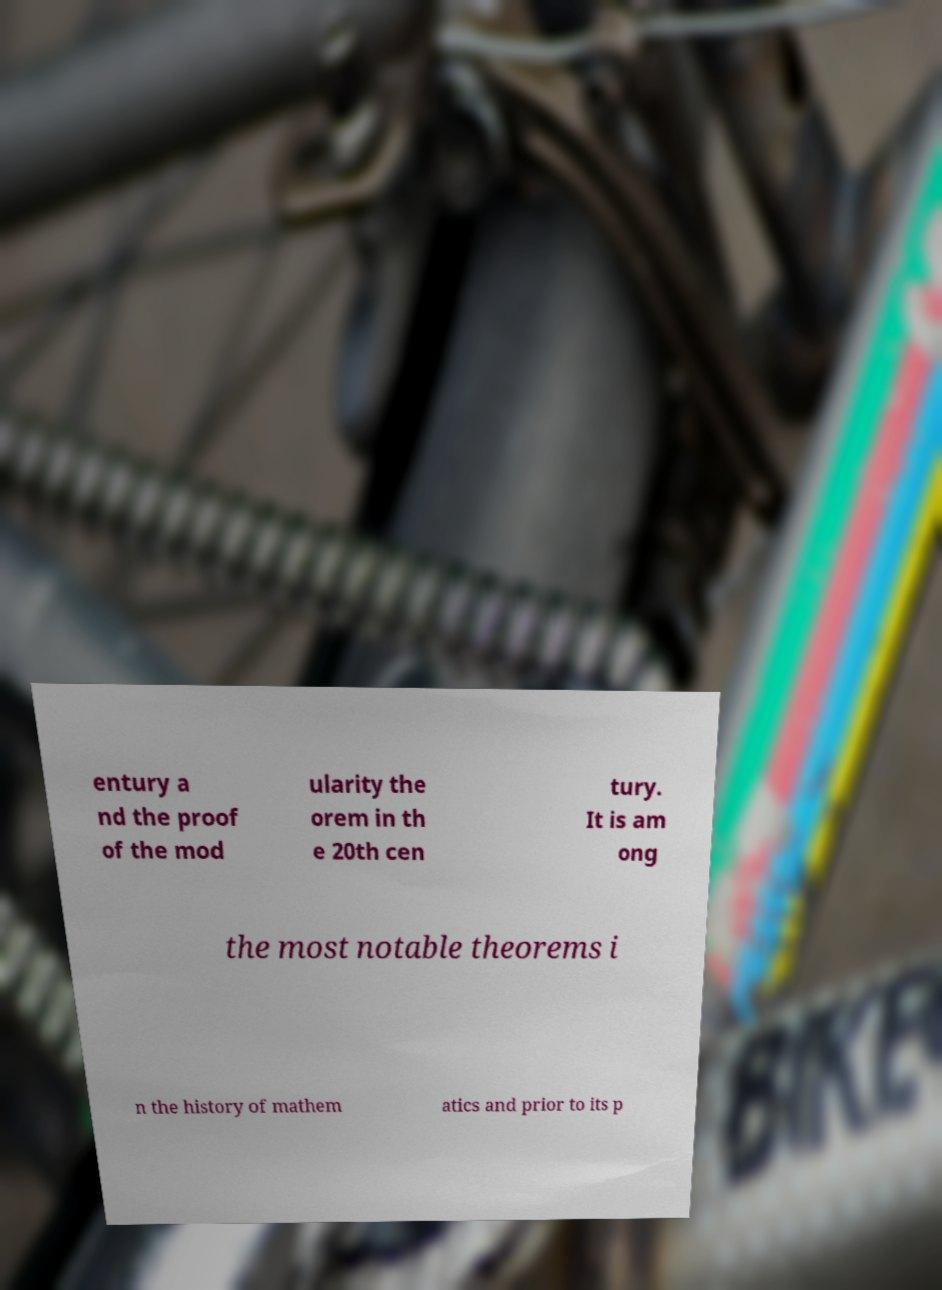For documentation purposes, I need the text within this image transcribed. Could you provide that? entury a nd the proof of the mod ularity the orem in th e 20th cen tury. It is am ong the most notable theorems i n the history of mathem atics and prior to its p 